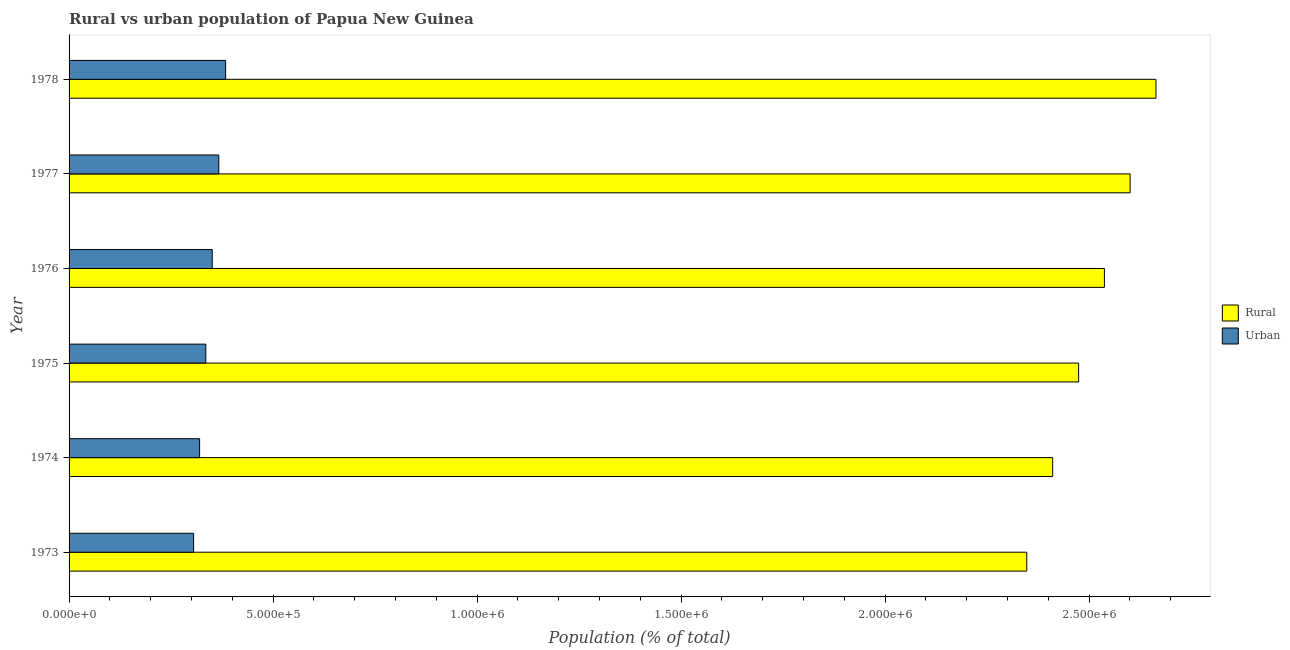How many different coloured bars are there?
Provide a succinct answer. 2. How many groups of bars are there?
Provide a succinct answer. 6. Are the number of bars per tick equal to the number of legend labels?
Ensure brevity in your answer.  Yes. How many bars are there on the 5th tick from the top?
Provide a short and direct response. 2. What is the label of the 5th group of bars from the top?
Offer a terse response. 1974. What is the urban population density in 1974?
Provide a short and direct response. 3.20e+05. Across all years, what is the maximum rural population density?
Your response must be concise. 2.66e+06. Across all years, what is the minimum rural population density?
Your response must be concise. 2.35e+06. In which year was the urban population density maximum?
Make the answer very short. 1978. What is the total rural population density in the graph?
Offer a terse response. 1.50e+07. What is the difference between the rural population density in 1974 and that in 1976?
Provide a succinct answer. -1.27e+05. What is the difference between the rural population density in 1975 and the urban population density in 1973?
Provide a succinct answer. 2.17e+06. What is the average rural population density per year?
Offer a terse response. 2.51e+06. In the year 1978, what is the difference between the urban population density and rural population density?
Give a very brief answer. -2.28e+06. In how many years, is the rural population density greater than 1300000 %?
Offer a very short reply. 6. Is the rural population density in 1975 less than that in 1978?
Keep it short and to the point. Yes. What is the difference between the highest and the second highest rural population density?
Your answer should be compact. 6.34e+04. What is the difference between the highest and the lowest rural population density?
Ensure brevity in your answer.  3.17e+05. In how many years, is the urban population density greater than the average urban population density taken over all years?
Your response must be concise. 3. What does the 1st bar from the top in 1973 represents?
Provide a succinct answer. Urban. What does the 1st bar from the bottom in 1976 represents?
Make the answer very short. Rural. How many bars are there?
Give a very brief answer. 12. Does the graph contain any zero values?
Offer a terse response. No. Does the graph contain grids?
Make the answer very short. No. What is the title of the graph?
Offer a very short reply. Rural vs urban population of Papua New Guinea. What is the label or title of the X-axis?
Make the answer very short. Population (% of total). What is the label or title of the Y-axis?
Ensure brevity in your answer.  Year. What is the Population (% of total) in Rural in 1973?
Offer a very short reply. 2.35e+06. What is the Population (% of total) in Urban in 1973?
Provide a succinct answer. 3.05e+05. What is the Population (% of total) in Rural in 1974?
Your answer should be compact. 2.41e+06. What is the Population (% of total) in Urban in 1974?
Keep it short and to the point. 3.20e+05. What is the Population (% of total) in Rural in 1975?
Your response must be concise. 2.47e+06. What is the Population (% of total) in Urban in 1975?
Offer a very short reply. 3.35e+05. What is the Population (% of total) of Rural in 1976?
Give a very brief answer. 2.54e+06. What is the Population (% of total) in Urban in 1976?
Make the answer very short. 3.51e+05. What is the Population (% of total) in Rural in 1977?
Keep it short and to the point. 2.60e+06. What is the Population (% of total) of Urban in 1977?
Your answer should be compact. 3.67e+05. What is the Population (% of total) in Rural in 1978?
Offer a terse response. 2.66e+06. What is the Population (% of total) in Urban in 1978?
Give a very brief answer. 3.84e+05. Across all years, what is the maximum Population (% of total) in Rural?
Ensure brevity in your answer.  2.66e+06. Across all years, what is the maximum Population (% of total) of Urban?
Keep it short and to the point. 3.84e+05. Across all years, what is the minimum Population (% of total) in Rural?
Ensure brevity in your answer.  2.35e+06. Across all years, what is the minimum Population (% of total) of Urban?
Ensure brevity in your answer.  3.05e+05. What is the total Population (% of total) of Rural in the graph?
Offer a terse response. 1.50e+07. What is the total Population (% of total) of Urban in the graph?
Provide a short and direct response. 2.06e+06. What is the difference between the Population (% of total) of Rural in 1973 and that in 1974?
Provide a short and direct response. -6.35e+04. What is the difference between the Population (% of total) in Urban in 1973 and that in 1974?
Your response must be concise. -1.47e+04. What is the difference between the Population (% of total) in Rural in 1973 and that in 1975?
Give a very brief answer. -1.27e+05. What is the difference between the Population (% of total) in Urban in 1973 and that in 1975?
Your response must be concise. -3.00e+04. What is the difference between the Population (% of total) of Rural in 1973 and that in 1976?
Offer a very short reply. -1.90e+05. What is the difference between the Population (% of total) of Urban in 1973 and that in 1976?
Provide a short and direct response. -4.56e+04. What is the difference between the Population (% of total) in Rural in 1973 and that in 1977?
Keep it short and to the point. -2.53e+05. What is the difference between the Population (% of total) of Urban in 1973 and that in 1977?
Keep it short and to the point. -6.17e+04. What is the difference between the Population (% of total) in Rural in 1973 and that in 1978?
Give a very brief answer. -3.17e+05. What is the difference between the Population (% of total) of Urban in 1973 and that in 1978?
Give a very brief answer. -7.85e+04. What is the difference between the Population (% of total) of Rural in 1974 and that in 1975?
Your answer should be very brief. -6.36e+04. What is the difference between the Population (% of total) in Urban in 1974 and that in 1975?
Make the answer very short. -1.52e+04. What is the difference between the Population (% of total) of Rural in 1974 and that in 1976?
Make the answer very short. -1.27e+05. What is the difference between the Population (% of total) of Urban in 1974 and that in 1976?
Your answer should be very brief. -3.09e+04. What is the difference between the Population (% of total) of Rural in 1974 and that in 1977?
Ensure brevity in your answer.  -1.90e+05. What is the difference between the Population (% of total) of Urban in 1974 and that in 1977?
Your response must be concise. -4.70e+04. What is the difference between the Population (% of total) in Rural in 1974 and that in 1978?
Your answer should be compact. -2.53e+05. What is the difference between the Population (% of total) of Urban in 1974 and that in 1978?
Offer a very short reply. -6.37e+04. What is the difference between the Population (% of total) in Rural in 1975 and that in 1976?
Your answer should be very brief. -6.31e+04. What is the difference between the Population (% of total) of Urban in 1975 and that in 1976?
Your answer should be very brief. -1.57e+04. What is the difference between the Population (% of total) of Rural in 1975 and that in 1977?
Give a very brief answer. -1.26e+05. What is the difference between the Population (% of total) of Urban in 1975 and that in 1977?
Provide a succinct answer. -3.18e+04. What is the difference between the Population (% of total) in Rural in 1975 and that in 1978?
Keep it short and to the point. -1.90e+05. What is the difference between the Population (% of total) in Urban in 1975 and that in 1978?
Keep it short and to the point. -4.85e+04. What is the difference between the Population (% of total) of Rural in 1976 and that in 1977?
Make the answer very short. -6.30e+04. What is the difference between the Population (% of total) of Urban in 1976 and that in 1977?
Make the answer very short. -1.61e+04. What is the difference between the Population (% of total) of Rural in 1976 and that in 1978?
Make the answer very short. -1.26e+05. What is the difference between the Population (% of total) in Urban in 1976 and that in 1978?
Provide a succinct answer. -3.28e+04. What is the difference between the Population (% of total) in Rural in 1977 and that in 1978?
Ensure brevity in your answer.  -6.34e+04. What is the difference between the Population (% of total) of Urban in 1977 and that in 1978?
Offer a very short reply. -1.67e+04. What is the difference between the Population (% of total) of Rural in 1973 and the Population (% of total) of Urban in 1974?
Your answer should be compact. 2.03e+06. What is the difference between the Population (% of total) of Rural in 1973 and the Population (% of total) of Urban in 1975?
Your answer should be compact. 2.01e+06. What is the difference between the Population (% of total) in Rural in 1973 and the Population (% of total) in Urban in 1976?
Make the answer very short. 2.00e+06. What is the difference between the Population (% of total) in Rural in 1973 and the Population (% of total) in Urban in 1977?
Provide a succinct answer. 1.98e+06. What is the difference between the Population (% of total) of Rural in 1973 and the Population (% of total) of Urban in 1978?
Offer a very short reply. 1.96e+06. What is the difference between the Population (% of total) of Rural in 1974 and the Population (% of total) of Urban in 1975?
Your answer should be compact. 2.08e+06. What is the difference between the Population (% of total) of Rural in 1974 and the Population (% of total) of Urban in 1976?
Give a very brief answer. 2.06e+06. What is the difference between the Population (% of total) in Rural in 1974 and the Population (% of total) in Urban in 1977?
Provide a short and direct response. 2.04e+06. What is the difference between the Population (% of total) of Rural in 1974 and the Population (% of total) of Urban in 1978?
Offer a very short reply. 2.03e+06. What is the difference between the Population (% of total) in Rural in 1975 and the Population (% of total) in Urban in 1976?
Ensure brevity in your answer.  2.12e+06. What is the difference between the Population (% of total) of Rural in 1975 and the Population (% of total) of Urban in 1977?
Provide a succinct answer. 2.11e+06. What is the difference between the Population (% of total) in Rural in 1975 and the Population (% of total) in Urban in 1978?
Give a very brief answer. 2.09e+06. What is the difference between the Population (% of total) in Rural in 1976 and the Population (% of total) in Urban in 1977?
Provide a short and direct response. 2.17e+06. What is the difference between the Population (% of total) of Rural in 1976 and the Population (% of total) of Urban in 1978?
Your answer should be compact. 2.15e+06. What is the difference between the Population (% of total) of Rural in 1977 and the Population (% of total) of Urban in 1978?
Provide a succinct answer. 2.22e+06. What is the average Population (% of total) of Rural per year?
Your answer should be very brief. 2.51e+06. What is the average Population (% of total) in Urban per year?
Your response must be concise. 3.44e+05. In the year 1973, what is the difference between the Population (% of total) of Rural and Population (% of total) of Urban?
Offer a terse response. 2.04e+06. In the year 1974, what is the difference between the Population (% of total) of Rural and Population (% of total) of Urban?
Your response must be concise. 2.09e+06. In the year 1975, what is the difference between the Population (% of total) of Rural and Population (% of total) of Urban?
Make the answer very short. 2.14e+06. In the year 1976, what is the difference between the Population (% of total) of Rural and Population (% of total) of Urban?
Keep it short and to the point. 2.19e+06. In the year 1977, what is the difference between the Population (% of total) in Rural and Population (% of total) in Urban?
Your response must be concise. 2.23e+06. In the year 1978, what is the difference between the Population (% of total) of Rural and Population (% of total) of Urban?
Ensure brevity in your answer.  2.28e+06. What is the ratio of the Population (% of total) of Rural in 1973 to that in 1974?
Provide a succinct answer. 0.97. What is the ratio of the Population (% of total) in Urban in 1973 to that in 1974?
Keep it short and to the point. 0.95. What is the ratio of the Population (% of total) of Rural in 1973 to that in 1975?
Provide a short and direct response. 0.95. What is the ratio of the Population (% of total) in Urban in 1973 to that in 1975?
Your response must be concise. 0.91. What is the ratio of the Population (% of total) of Rural in 1973 to that in 1976?
Keep it short and to the point. 0.93. What is the ratio of the Population (% of total) of Urban in 1973 to that in 1976?
Offer a very short reply. 0.87. What is the ratio of the Population (% of total) of Rural in 1973 to that in 1977?
Keep it short and to the point. 0.9. What is the ratio of the Population (% of total) in Urban in 1973 to that in 1977?
Ensure brevity in your answer.  0.83. What is the ratio of the Population (% of total) of Rural in 1973 to that in 1978?
Keep it short and to the point. 0.88. What is the ratio of the Population (% of total) of Urban in 1973 to that in 1978?
Your answer should be compact. 0.8. What is the ratio of the Population (% of total) in Rural in 1974 to that in 1975?
Your answer should be compact. 0.97. What is the ratio of the Population (% of total) in Urban in 1974 to that in 1975?
Offer a very short reply. 0.95. What is the ratio of the Population (% of total) in Rural in 1974 to that in 1976?
Offer a terse response. 0.95. What is the ratio of the Population (% of total) of Urban in 1974 to that in 1976?
Ensure brevity in your answer.  0.91. What is the ratio of the Population (% of total) of Rural in 1974 to that in 1977?
Provide a succinct answer. 0.93. What is the ratio of the Population (% of total) in Urban in 1974 to that in 1977?
Offer a very short reply. 0.87. What is the ratio of the Population (% of total) of Rural in 1974 to that in 1978?
Give a very brief answer. 0.91. What is the ratio of the Population (% of total) in Urban in 1974 to that in 1978?
Ensure brevity in your answer.  0.83. What is the ratio of the Population (% of total) of Rural in 1975 to that in 1976?
Your answer should be very brief. 0.98. What is the ratio of the Population (% of total) of Urban in 1975 to that in 1976?
Your answer should be compact. 0.96. What is the ratio of the Population (% of total) in Rural in 1975 to that in 1977?
Your response must be concise. 0.95. What is the ratio of the Population (% of total) in Urban in 1975 to that in 1977?
Offer a very short reply. 0.91. What is the ratio of the Population (% of total) of Rural in 1975 to that in 1978?
Ensure brevity in your answer.  0.93. What is the ratio of the Population (% of total) in Urban in 1975 to that in 1978?
Your answer should be very brief. 0.87. What is the ratio of the Population (% of total) in Rural in 1976 to that in 1977?
Offer a very short reply. 0.98. What is the ratio of the Population (% of total) of Urban in 1976 to that in 1977?
Give a very brief answer. 0.96. What is the ratio of the Population (% of total) in Rural in 1976 to that in 1978?
Give a very brief answer. 0.95. What is the ratio of the Population (% of total) of Urban in 1976 to that in 1978?
Provide a succinct answer. 0.91. What is the ratio of the Population (% of total) of Rural in 1977 to that in 1978?
Your response must be concise. 0.98. What is the ratio of the Population (% of total) of Urban in 1977 to that in 1978?
Offer a very short reply. 0.96. What is the difference between the highest and the second highest Population (% of total) in Rural?
Give a very brief answer. 6.34e+04. What is the difference between the highest and the second highest Population (% of total) in Urban?
Keep it short and to the point. 1.67e+04. What is the difference between the highest and the lowest Population (% of total) in Rural?
Provide a succinct answer. 3.17e+05. What is the difference between the highest and the lowest Population (% of total) of Urban?
Your answer should be compact. 7.85e+04. 